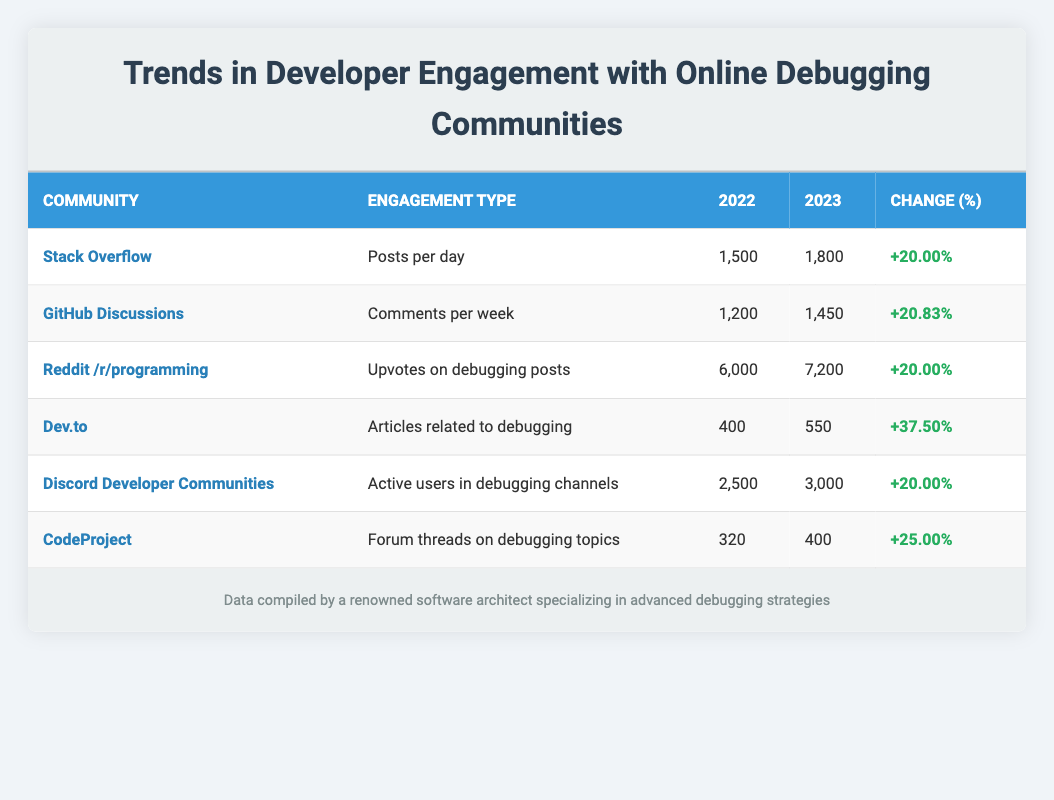What is the engagement type for Stack Overflow? The table lists various communities along with the type of engagement for each. For Stack Overflow, the engagement type is specified as "Posts per day".
Answer: Posts per day How many upvotes on debugging posts were there in Reddit /r/programming for 2022? The table shows the statistics for Reddit /r/programming, under the column "2022", the value for upvotes on debugging posts is recorded as 6000.
Answer: 6000 Which community had the highest percentage change in engagement from 2022 to 2023? By examining the "Change (%)" column, we see that Dev.to shows the highest percentage increase of 37.5%, compared to the other communities.
Answer: Dev.to Calculate the average number of posts per day across all communities in 2023. We will take the engagement values for 2023: 1800 (Stack Overflow), 1450 (GitHub Discussions), 7200 (Reddit), 550 (Dev.to), 3000 (Discord), and 400 (CodeProject). The sum is 1800 + 1450 + 7200 + 550 + 3000 + 400 = 15300. There are 6 communities, so the average is 15300 / 6 = 2550.
Answer: 2550 Is there an increase in active users for Discord Developer Communities from 2022 to 2023? Looking at the values for Discord Developer Communities in 2022 and 2023, it increased from 2500 to 3000, indicating a positive change. Therefore, the answer to the question is yes.
Answer: Yes What was the number of forum threads on debugging topics in CodeProject in 2023? The table provides a specific value for CodeProject's forum threads on debugging topics for 2023, which is stated clearly as 400.
Answer: 400 What is the total number of comments per week across GitHub Discussions and active users in Discord Developer Communities in 2023? Adding the values for GitHub Discussions (1450 comments per week) and Discord Developer Communities (3000 active users) gives us 1450 + 3000 = 4450.
Answer: 4450 Did the number of articles related to debugging on Dev.to decrease from 2022 to 2023? By comparing the values, Dev.to shows an increase from 400 articles in 2022 to 550 articles in 2023; thus, it did not decrease.
Answer: No Which community experienced a growth rate of exactly 20% in engagement? By reviewing the change percentage column, we can find that Stack Overflow, Reddit /r/programming, and Discord Developer Communities all experienced a growth rate of exactly 20%.
Answer: Stack Overflow, Reddit /r/programming, Discord Developer Communities 